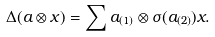Convert formula to latex. <formula><loc_0><loc_0><loc_500><loc_500>\Delta ( a \otimes x ) = \sum a _ { ( 1 ) } \otimes \sigma ( a _ { ( 2 ) } ) x .</formula> 